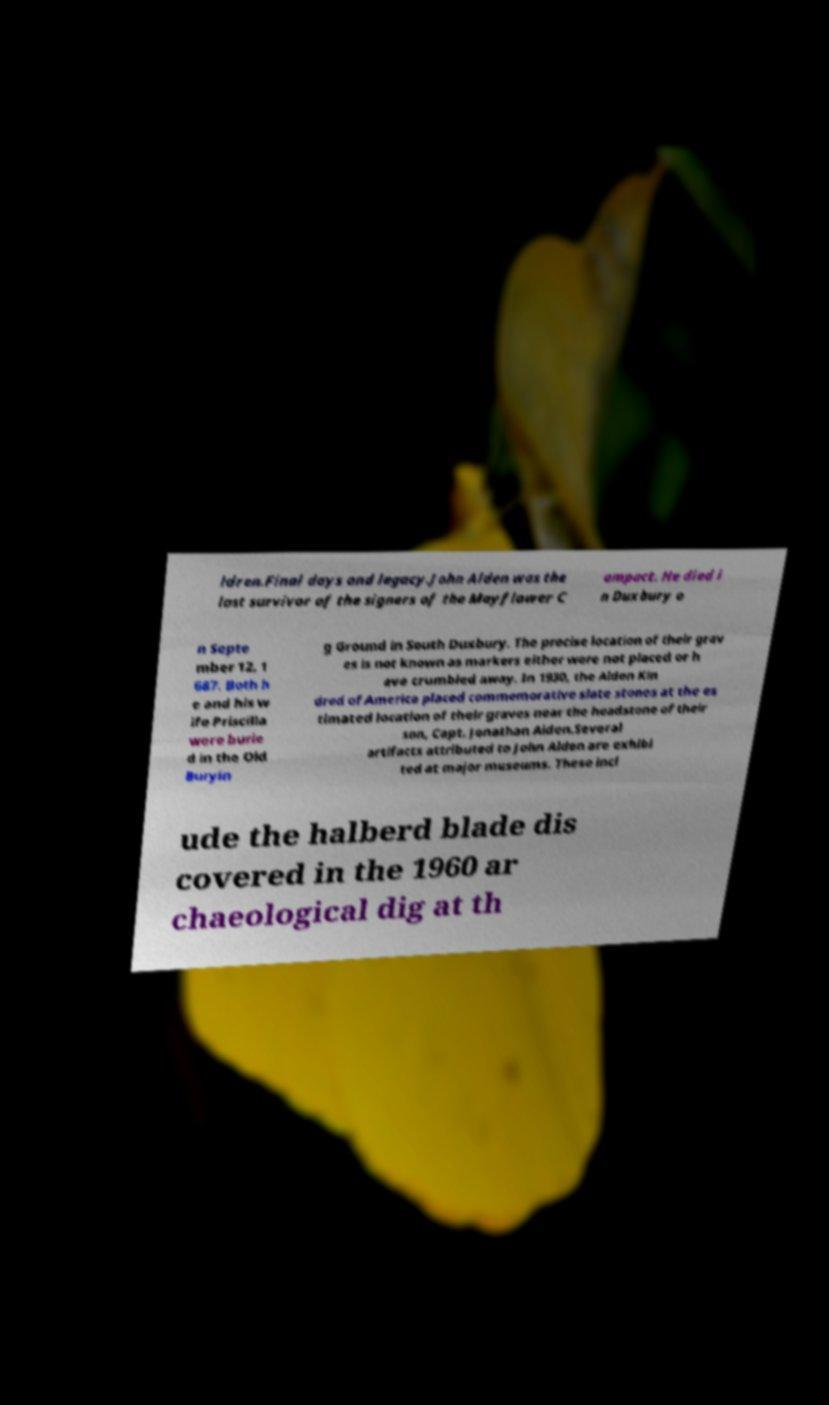Please read and relay the text visible in this image. What does it say? ldren.Final days and legacy.John Alden was the last survivor of the signers of the Mayflower C ompact. He died i n Duxbury o n Septe mber 12, 1 687. Both h e and his w ife Priscilla were burie d in the Old Buryin g Ground in South Duxbury. The precise location of their grav es is not known as markers either were not placed or h ave crumbled away. In 1930, the Alden Kin dred of America placed commemorative slate stones at the es timated location of their graves near the headstone of their son, Capt. Jonathan Alden.Several artifacts attributed to John Alden are exhibi ted at major museums. These incl ude the halberd blade dis covered in the 1960 ar chaeological dig at th 